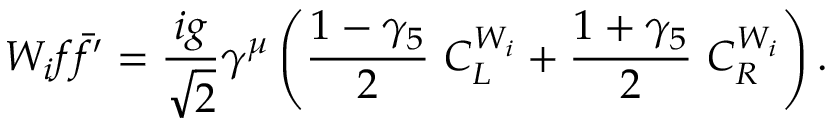Convert formula to latex. <formula><loc_0><loc_0><loc_500><loc_500>W _ { i } f \bar { f } ^ { \prime } = \frac { i g } { \sqrt { 2 } } \gamma ^ { \mu } \left ( \frac { 1 - \gamma _ { 5 } } { 2 } \, C _ { L } ^ { W _ { i } } + \frac { 1 + \gamma _ { 5 } } { 2 } \, C _ { R } ^ { W _ { i } } \right ) .</formula> 